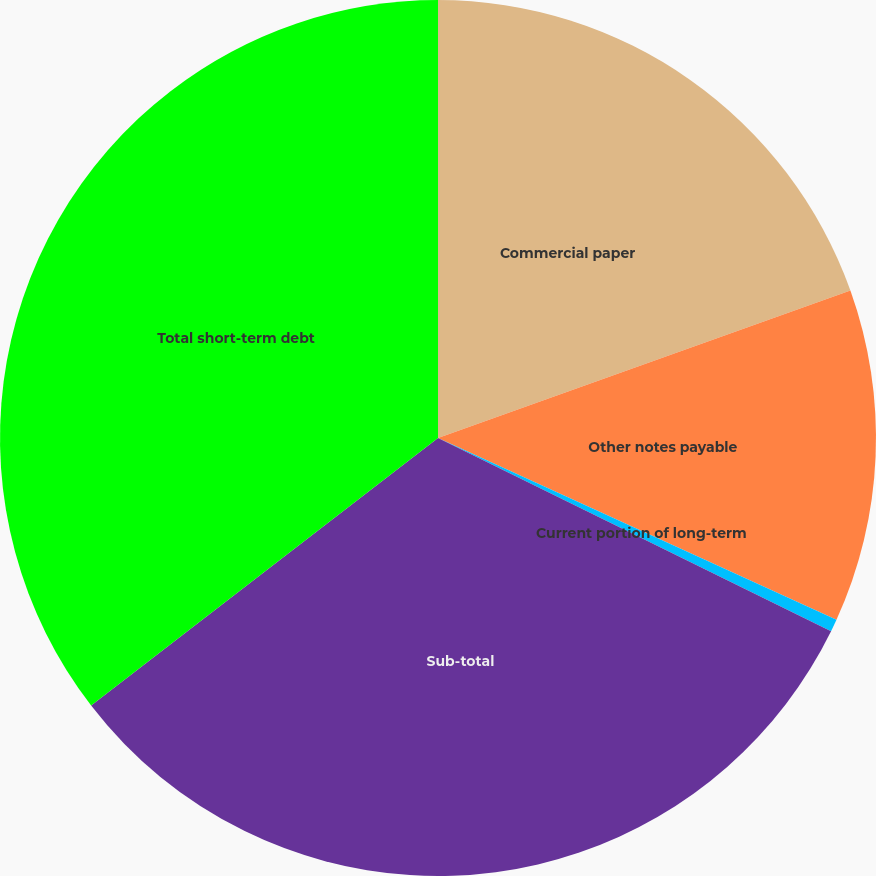<chart> <loc_0><loc_0><loc_500><loc_500><pie_chart><fcel>Commercial paper<fcel>Other notes payable<fcel>Current portion of long-term<fcel>Sub-total<fcel>Total short-term debt<nl><fcel>19.53%<fcel>12.28%<fcel>0.46%<fcel>32.27%<fcel>35.45%<nl></chart> 